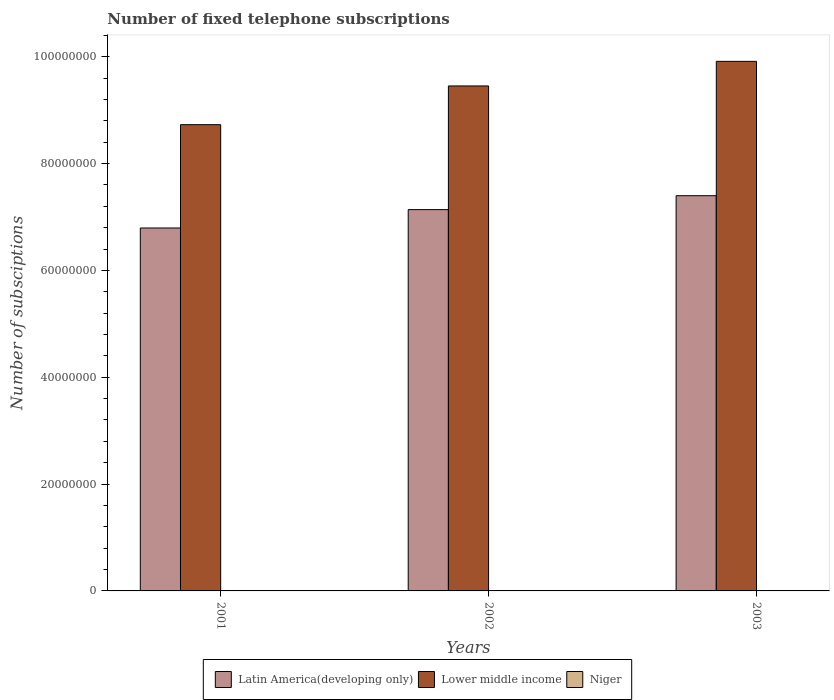How many different coloured bars are there?
Provide a short and direct response. 3. How many groups of bars are there?
Keep it short and to the point. 3. What is the label of the 2nd group of bars from the left?
Your response must be concise. 2002. What is the number of fixed telephone subscriptions in Niger in 2003?
Provide a short and direct response. 2.30e+04. Across all years, what is the maximum number of fixed telephone subscriptions in Niger?
Ensure brevity in your answer.  2.30e+04. Across all years, what is the minimum number of fixed telephone subscriptions in Niger?
Ensure brevity in your answer.  2.17e+04. In which year was the number of fixed telephone subscriptions in Latin America(developing only) maximum?
Your answer should be compact. 2003. In which year was the number of fixed telephone subscriptions in Latin America(developing only) minimum?
Give a very brief answer. 2001. What is the total number of fixed telephone subscriptions in Latin America(developing only) in the graph?
Provide a short and direct response. 2.13e+08. What is the difference between the number of fixed telephone subscriptions in Lower middle income in 2001 and that in 2003?
Your response must be concise. -1.19e+07. What is the difference between the number of fixed telephone subscriptions in Niger in 2003 and the number of fixed telephone subscriptions in Lower middle income in 2001?
Offer a very short reply. -8.73e+07. What is the average number of fixed telephone subscriptions in Latin America(developing only) per year?
Your response must be concise. 7.11e+07. In the year 2002, what is the difference between the number of fixed telephone subscriptions in Niger and number of fixed telephone subscriptions in Latin America(developing only)?
Provide a short and direct response. -7.14e+07. In how many years, is the number of fixed telephone subscriptions in Lower middle income greater than 56000000?
Ensure brevity in your answer.  3. What is the ratio of the number of fixed telephone subscriptions in Niger in 2001 to that in 2002?
Give a very brief answer. 0.97. Is the number of fixed telephone subscriptions in Niger in 2002 less than that in 2003?
Your answer should be very brief. Yes. Is the difference between the number of fixed telephone subscriptions in Niger in 2001 and 2002 greater than the difference between the number of fixed telephone subscriptions in Latin America(developing only) in 2001 and 2002?
Offer a terse response. Yes. What is the difference between the highest and the second highest number of fixed telephone subscriptions in Lower middle income?
Your answer should be compact. 4.60e+06. What is the difference between the highest and the lowest number of fixed telephone subscriptions in Niger?
Your response must be concise. 1306. What does the 2nd bar from the left in 2001 represents?
Provide a succinct answer. Lower middle income. What does the 3rd bar from the right in 2002 represents?
Keep it short and to the point. Latin America(developing only). Is it the case that in every year, the sum of the number of fixed telephone subscriptions in Latin America(developing only) and number of fixed telephone subscriptions in Niger is greater than the number of fixed telephone subscriptions in Lower middle income?
Your answer should be very brief. No. How many bars are there?
Ensure brevity in your answer.  9. How many years are there in the graph?
Your response must be concise. 3. Does the graph contain any zero values?
Your response must be concise. No. Does the graph contain grids?
Your response must be concise. No. Where does the legend appear in the graph?
Offer a terse response. Bottom center. What is the title of the graph?
Keep it short and to the point. Number of fixed telephone subscriptions. Does "Middle East & North Africa (developing only)" appear as one of the legend labels in the graph?
Offer a terse response. No. What is the label or title of the Y-axis?
Offer a terse response. Number of subsciptions. What is the Number of subsciptions of Latin America(developing only) in 2001?
Give a very brief answer. 6.79e+07. What is the Number of subsciptions in Lower middle income in 2001?
Offer a very short reply. 8.73e+07. What is the Number of subsciptions in Niger in 2001?
Offer a very short reply. 2.17e+04. What is the Number of subsciptions in Latin America(developing only) in 2002?
Your response must be concise. 7.14e+07. What is the Number of subsciptions of Lower middle income in 2002?
Your answer should be very brief. 9.45e+07. What is the Number of subsciptions in Niger in 2002?
Provide a succinct answer. 2.24e+04. What is the Number of subsciptions in Latin America(developing only) in 2003?
Provide a short and direct response. 7.40e+07. What is the Number of subsciptions in Lower middle income in 2003?
Make the answer very short. 9.91e+07. What is the Number of subsciptions of Niger in 2003?
Offer a very short reply. 2.30e+04. Across all years, what is the maximum Number of subsciptions in Latin America(developing only)?
Keep it short and to the point. 7.40e+07. Across all years, what is the maximum Number of subsciptions in Lower middle income?
Your answer should be very brief. 9.91e+07. Across all years, what is the maximum Number of subsciptions of Niger?
Make the answer very short. 2.30e+04. Across all years, what is the minimum Number of subsciptions in Latin America(developing only)?
Make the answer very short. 6.79e+07. Across all years, what is the minimum Number of subsciptions in Lower middle income?
Make the answer very short. 8.73e+07. Across all years, what is the minimum Number of subsciptions in Niger?
Offer a terse response. 2.17e+04. What is the total Number of subsciptions in Latin America(developing only) in the graph?
Offer a terse response. 2.13e+08. What is the total Number of subsciptions of Lower middle income in the graph?
Ensure brevity in your answer.  2.81e+08. What is the total Number of subsciptions in Niger in the graph?
Make the answer very short. 6.70e+04. What is the difference between the Number of subsciptions in Latin America(developing only) in 2001 and that in 2002?
Provide a short and direct response. -3.44e+06. What is the difference between the Number of subsciptions of Lower middle income in 2001 and that in 2002?
Ensure brevity in your answer.  -7.25e+06. What is the difference between the Number of subsciptions of Niger in 2001 and that in 2002?
Ensure brevity in your answer.  -730. What is the difference between the Number of subsciptions in Latin America(developing only) in 2001 and that in 2003?
Your response must be concise. -6.04e+06. What is the difference between the Number of subsciptions of Lower middle income in 2001 and that in 2003?
Keep it short and to the point. -1.19e+07. What is the difference between the Number of subsciptions of Niger in 2001 and that in 2003?
Make the answer very short. -1306. What is the difference between the Number of subsciptions of Latin America(developing only) in 2002 and that in 2003?
Offer a very short reply. -2.60e+06. What is the difference between the Number of subsciptions in Lower middle income in 2002 and that in 2003?
Give a very brief answer. -4.60e+06. What is the difference between the Number of subsciptions in Niger in 2002 and that in 2003?
Make the answer very short. -576. What is the difference between the Number of subsciptions of Latin America(developing only) in 2001 and the Number of subsciptions of Lower middle income in 2002?
Your response must be concise. -2.66e+07. What is the difference between the Number of subsciptions in Latin America(developing only) in 2001 and the Number of subsciptions in Niger in 2002?
Keep it short and to the point. 6.79e+07. What is the difference between the Number of subsciptions of Lower middle income in 2001 and the Number of subsciptions of Niger in 2002?
Your answer should be compact. 8.73e+07. What is the difference between the Number of subsciptions of Latin America(developing only) in 2001 and the Number of subsciptions of Lower middle income in 2003?
Ensure brevity in your answer.  -3.12e+07. What is the difference between the Number of subsciptions in Latin America(developing only) in 2001 and the Number of subsciptions in Niger in 2003?
Provide a succinct answer. 6.79e+07. What is the difference between the Number of subsciptions in Lower middle income in 2001 and the Number of subsciptions in Niger in 2003?
Your answer should be very brief. 8.73e+07. What is the difference between the Number of subsciptions in Latin America(developing only) in 2002 and the Number of subsciptions in Lower middle income in 2003?
Provide a short and direct response. -2.78e+07. What is the difference between the Number of subsciptions of Latin America(developing only) in 2002 and the Number of subsciptions of Niger in 2003?
Provide a short and direct response. 7.14e+07. What is the difference between the Number of subsciptions of Lower middle income in 2002 and the Number of subsciptions of Niger in 2003?
Offer a terse response. 9.45e+07. What is the average Number of subsciptions in Latin America(developing only) per year?
Ensure brevity in your answer.  7.11e+07. What is the average Number of subsciptions of Lower middle income per year?
Provide a short and direct response. 9.36e+07. What is the average Number of subsciptions in Niger per year?
Your answer should be very brief. 2.23e+04. In the year 2001, what is the difference between the Number of subsciptions in Latin America(developing only) and Number of subsciptions in Lower middle income?
Your response must be concise. -1.93e+07. In the year 2001, what is the difference between the Number of subsciptions in Latin America(developing only) and Number of subsciptions in Niger?
Offer a terse response. 6.79e+07. In the year 2001, what is the difference between the Number of subsciptions of Lower middle income and Number of subsciptions of Niger?
Your answer should be compact. 8.73e+07. In the year 2002, what is the difference between the Number of subsciptions of Latin America(developing only) and Number of subsciptions of Lower middle income?
Offer a very short reply. -2.32e+07. In the year 2002, what is the difference between the Number of subsciptions of Latin America(developing only) and Number of subsciptions of Niger?
Ensure brevity in your answer.  7.14e+07. In the year 2002, what is the difference between the Number of subsciptions of Lower middle income and Number of subsciptions of Niger?
Your answer should be compact. 9.45e+07. In the year 2003, what is the difference between the Number of subsciptions of Latin America(developing only) and Number of subsciptions of Lower middle income?
Ensure brevity in your answer.  -2.52e+07. In the year 2003, what is the difference between the Number of subsciptions of Latin America(developing only) and Number of subsciptions of Niger?
Your answer should be very brief. 7.40e+07. In the year 2003, what is the difference between the Number of subsciptions in Lower middle income and Number of subsciptions in Niger?
Your answer should be compact. 9.91e+07. What is the ratio of the Number of subsciptions of Latin America(developing only) in 2001 to that in 2002?
Your response must be concise. 0.95. What is the ratio of the Number of subsciptions in Lower middle income in 2001 to that in 2002?
Provide a succinct answer. 0.92. What is the ratio of the Number of subsciptions in Niger in 2001 to that in 2002?
Ensure brevity in your answer.  0.97. What is the ratio of the Number of subsciptions of Latin America(developing only) in 2001 to that in 2003?
Ensure brevity in your answer.  0.92. What is the ratio of the Number of subsciptions of Lower middle income in 2001 to that in 2003?
Offer a terse response. 0.88. What is the ratio of the Number of subsciptions in Niger in 2001 to that in 2003?
Give a very brief answer. 0.94. What is the ratio of the Number of subsciptions of Latin America(developing only) in 2002 to that in 2003?
Offer a terse response. 0.96. What is the ratio of the Number of subsciptions in Lower middle income in 2002 to that in 2003?
Your response must be concise. 0.95. What is the ratio of the Number of subsciptions of Niger in 2002 to that in 2003?
Provide a succinct answer. 0.97. What is the difference between the highest and the second highest Number of subsciptions in Latin America(developing only)?
Make the answer very short. 2.60e+06. What is the difference between the highest and the second highest Number of subsciptions of Lower middle income?
Your answer should be very brief. 4.60e+06. What is the difference between the highest and the second highest Number of subsciptions in Niger?
Your answer should be compact. 576. What is the difference between the highest and the lowest Number of subsciptions of Latin America(developing only)?
Make the answer very short. 6.04e+06. What is the difference between the highest and the lowest Number of subsciptions of Lower middle income?
Your response must be concise. 1.19e+07. What is the difference between the highest and the lowest Number of subsciptions in Niger?
Offer a very short reply. 1306. 